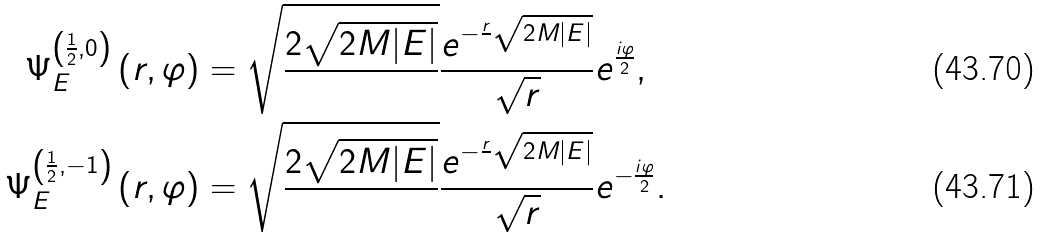<formula> <loc_0><loc_0><loc_500><loc_500>\Psi _ { E } ^ { \left ( \frac { 1 } { 2 } , 0 \right ) } \left ( r , \varphi \right ) & = \sqrt { \frac { 2 \sqrt { 2 M | E | } } { } } \frac { e ^ { - \frac { r } { } \sqrt { 2 M | E | } } } { \sqrt { r } } e ^ { \frac { i \varphi } { 2 } } , \\ \Psi _ { E } ^ { \left ( \frac { 1 } { 2 } , - 1 \right ) } \left ( r , \varphi \right ) & = \sqrt { \frac { 2 \sqrt { 2 M | E | } } { } } \frac { e ^ { - \frac { r } { } \sqrt { 2 M | E | } } } { \sqrt { r } } e ^ { - \frac { i \varphi } { 2 } } .</formula> 